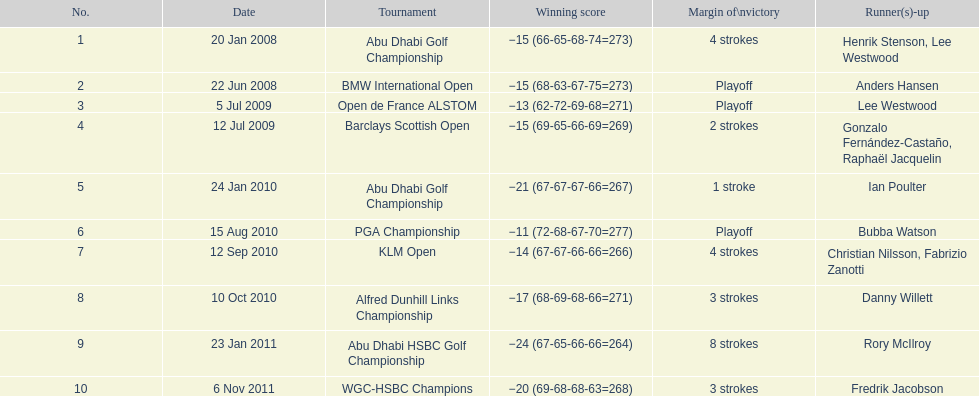What is the total count of tournaments he has triumphed in? 10. Could you parse the entire table? {'header': ['No.', 'Date', 'Tournament', 'Winning score', 'Margin of\\nvictory', 'Runner(s)-up'], 'rows': [['1', '20 Jan 2008', 'Abu Dhabi Golf Championship', '−15 (66-65-68-74=273)', '4 strokes', 'Henrik Stenson, Lee Westwood'], ['2', '22 Jun 2008', 'BMW International Open', '−15 (68-63-67-75=273)', 'Playoff', 'Anders Hansen'], ['3', '5 Jul 2009', 'Open de France ALSTOM', '−13 (62-72-69-68=271)', 'Playoff', 'Lee Westwood'], ['4', '12 Jul 2009', 'Barclays Scottish Open', '−15 (69-65-66-69=269)', '2 strokes', 'Gonzalo Fernández-Castaño, Raphaël Jacquelin'], ['5', '24 Jan 2010', 'Abu Dhabi Golf Championship', '−21 (67-67-67-66=267)', '1 stroke', 'Ian Poulter'], ['6', '15 Aug 2010', 'PGA Championship', '−11 (72-68-67-70=277)', 'Playoff', 'Bubba Watson'], ['7', '12 Sep 2010', 'KLM Open', '−14 (67-67-66-66=266)', '4 strokes', 'Christian Nilsson, Fabrizio Zanotti'], ['8', '10 Oct 2010', 'Alfred Dunhill Links Championship', '−17 (68-69-68-66=271)', '3 strokes', 'Danny Willett'], ['9', '23 Jan 2011', 'Abu Dhabi HSBC Golf Championship', '−24 (67-65-66-66=264)', '8 strokes', 'Rory McIlroy'], ['10', '6 Nov 2011', 'WGC-HSBC Champions', '−20 (69-68-68-63=268)', '3 strokes', 'Fredrik Jacobson']]} 